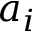Convert formula to latex. <formula><loc_0><loc_0><loc_500><loc_500>a _ { i }</formula> 